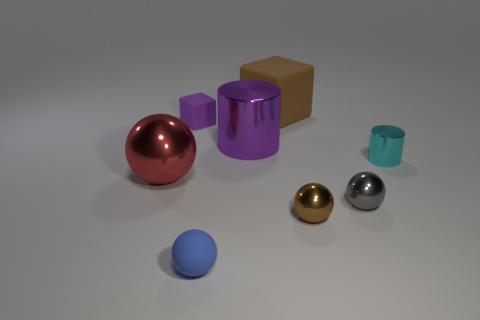Are there more small brown metallic spheres than purple objects?
Offer a very short reply. No. Are there any other things that are the same color as the big cube?
Provide a succinct answer. Yes. There is another small object that is the same material as the tiny blue object; what is its shape?
Your answer should be compact. Cube. What material is the brown thing that is in front of the rubber thing right of the blue rubber ball made of?
Offer a very short reply. Metal. There is a big shiny object that is behind the large red ball; is its shape the same as the big red metallic object?
Offer a very short reply. No. Are there more purple objects that are to the left of the purple metallic cylinder than small brown spheres?
Provide a short and direct response. No. Are there any other things that have the same material as the blue object?
Give a very brief answer. Yes. There is a large shiny object that is the same color as the tiny cube; what shape is it?
Your answer should be very brief. Cylinder. How many cubes are large brown objects or small objects?
Offer a terse response. 2. What color is the shiny cylinder that is on the left side of the brown thing behind the red sphere?
Your answer should be very brief. Purple. 